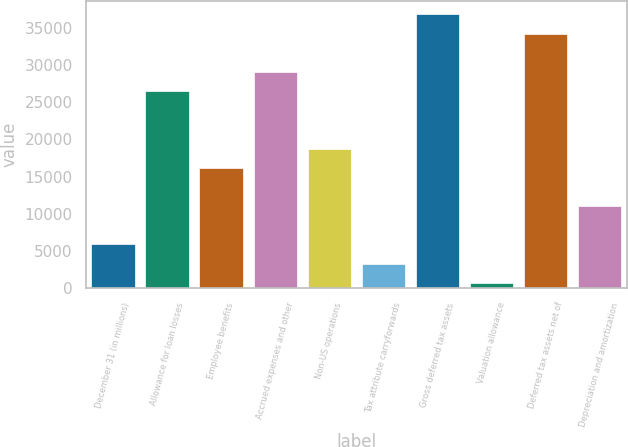<chart> <loc_0><loc_0><loc_500><loc_500><bar_chart><fcel>December 31 (in millions)<fcel>Allowance for loan losses<fcel>Employee benefits<fcel>Accrued expenses and other<fcel>Non-US operations<fcel>Tax attribute carryforwards<fcel>Gross deferred tax assets<fcel>Valuation allowance<fcel>Deferred tax assets net of<fcel>Depreciation and amortization<nl><fcel>5875.4<fcel>26481<fcel>16178.2<fcel>29056.7<fcel>18753.9<fcel>3299.7<fcel>36783.8<fcel>724<fcel>34208.1<fcel>11026.8<nl></chart> 